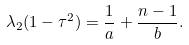Convert formula to latex. <formula><loc_0><loc_0><loc_500><loc_500>\lambda _ { 2 } ( 1 - \tau ^ { 2 } ) = \frac { 1 } { a } + \frac { n - 1 } { b } .</formula> 